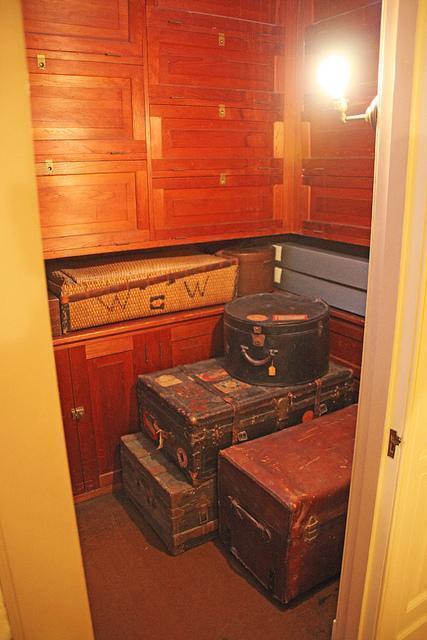How many cabinet locks are there?
Give a very brief answer. 6. How many suitcases are there?
Give a very brief answer. 3. How many kites are in the sky?
Give a very brief answer. 0. 